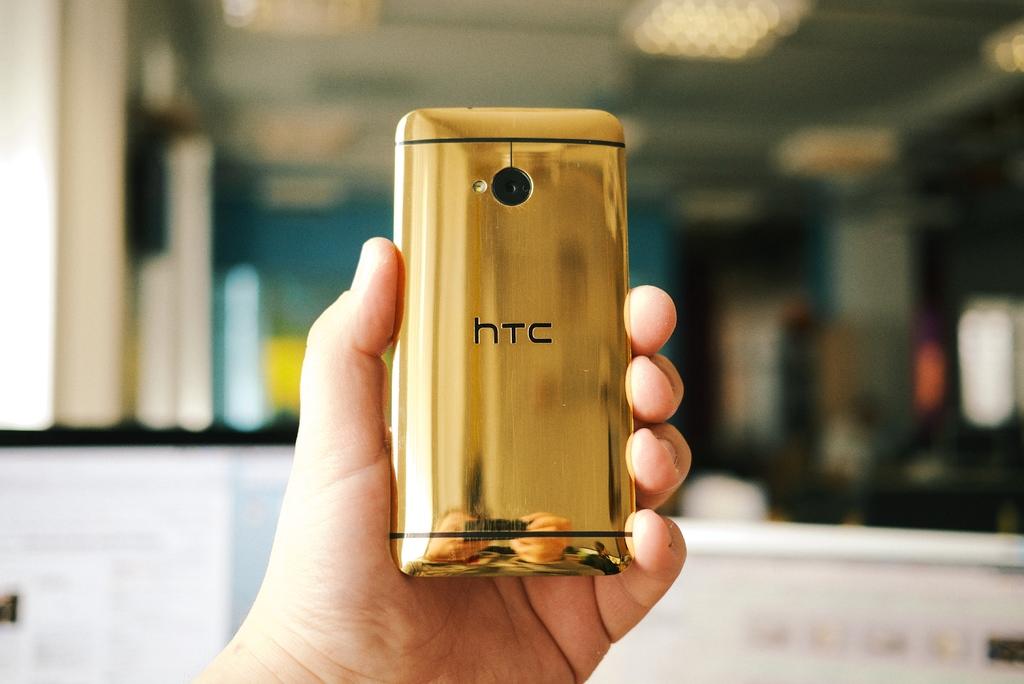Is this an htc phone?
Your answer should be compact. Yes. What kind of phone is this?
Your answer should be very brief. Htc. 